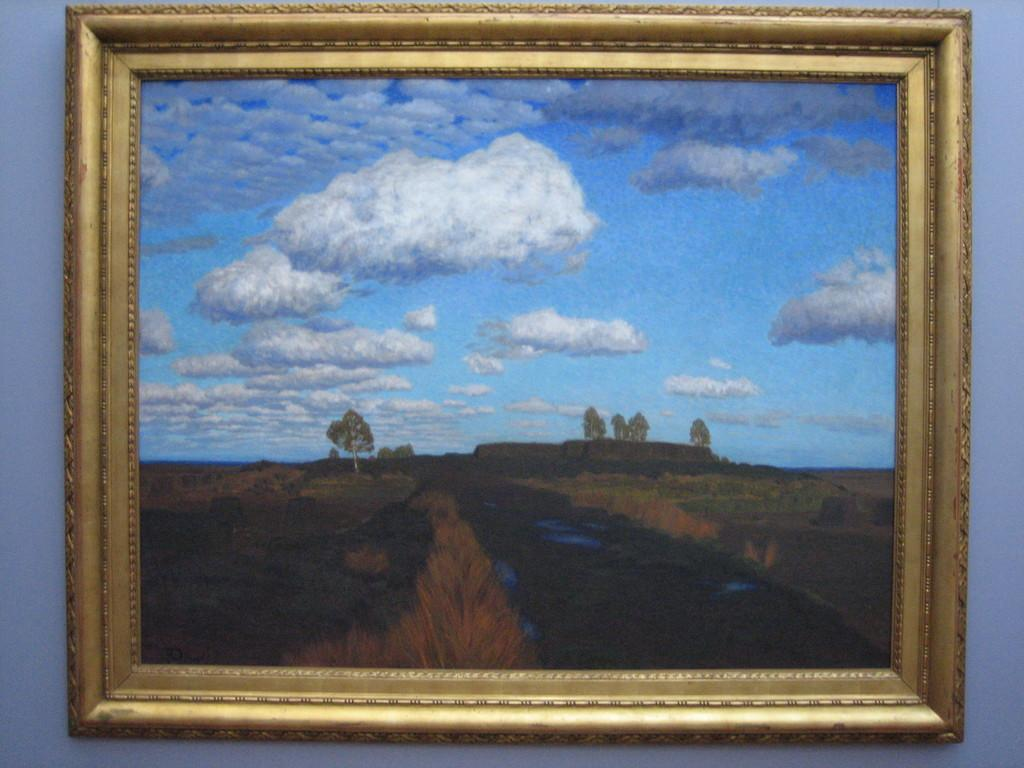What is hanging on the wall in the image? There is a photo frame on the wall in the image. What type of natural environment can be seen in the image? Trees and the sky are visible in the image. What is the condition of the sky in the image? Clouds are present in the sky. What type of bottle can be seen in the middle of the image? There is no bottle present in the image. Can you describe the skateboarding trick being performed in the image? There is no skateboarding or any related activity depicted in the image. 